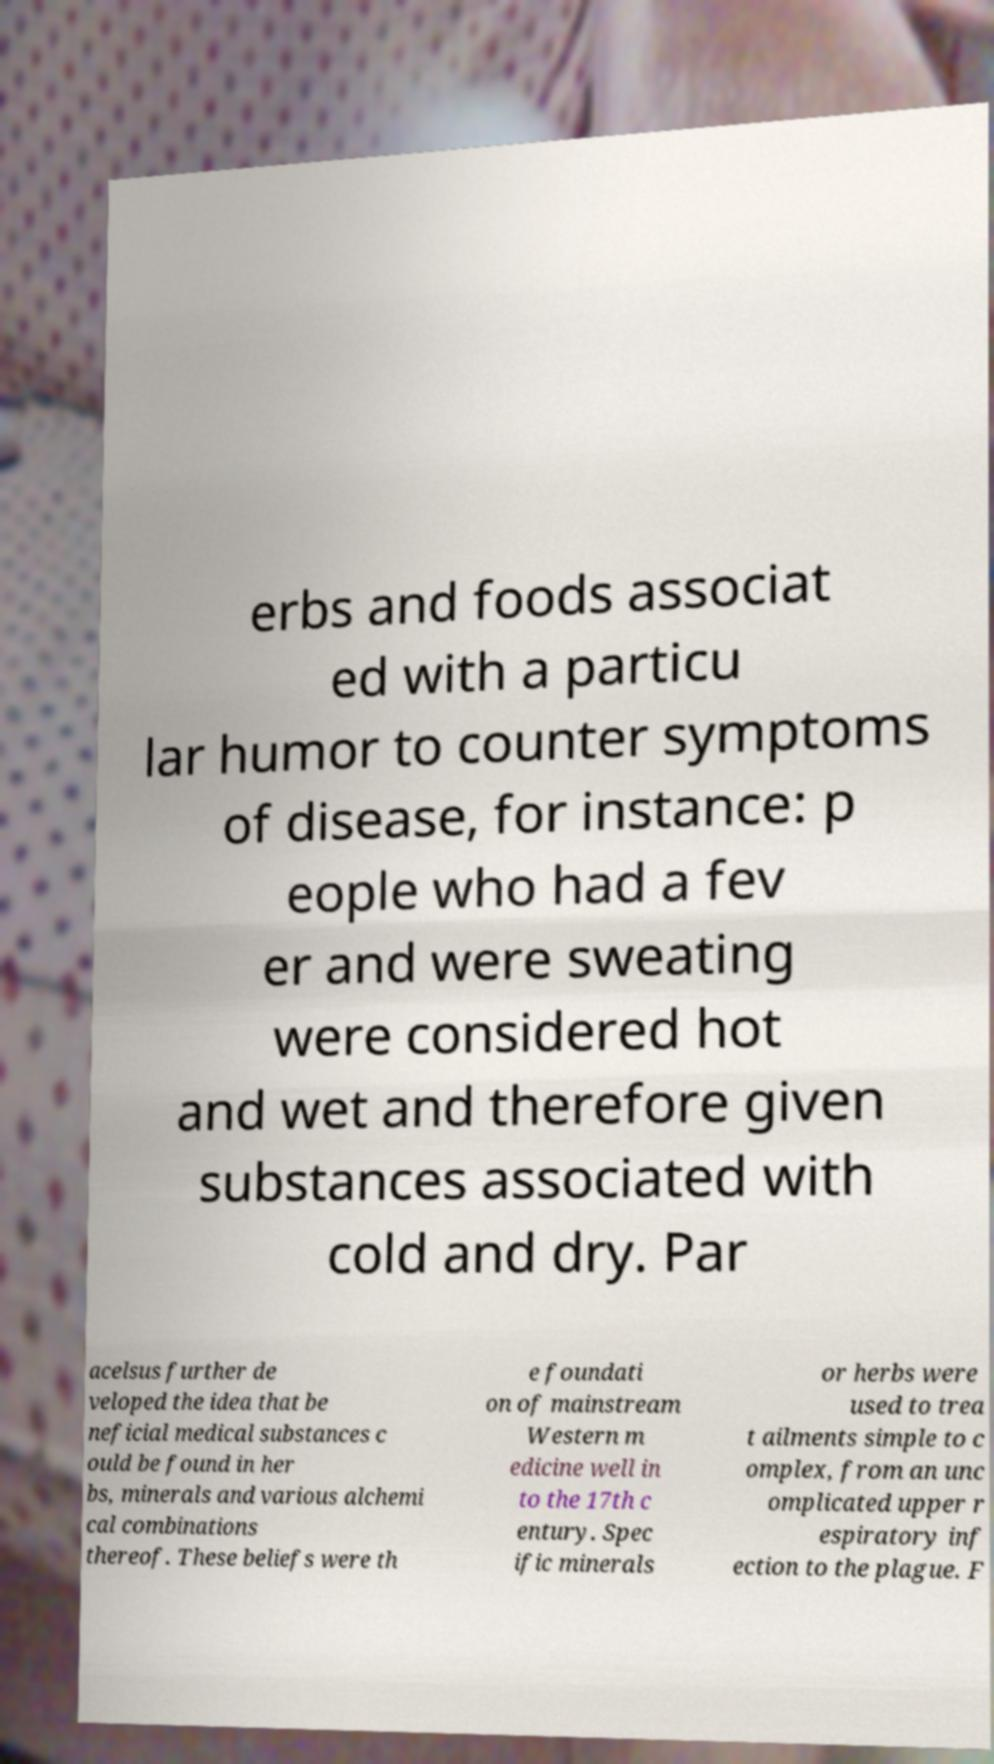For documentation purposes, I need the text within this image transcribed. Could you provide that? erbs and foods associat ed with a particu lar humor to counter symptoms of disease, for instance: p eople who had a fev er and were sweating were considered hot and wet and therefore given substances associated with cold and dry. Par acelsus further de veloped the idea that be neficial medical substances c ould be found in her bs, minerals and various alchemi cal combinations thereof. These beliefs were th e foundati on of mainstream Western m edicine well in to the 17th c entury. Spec ific minerals or herbs were used to trea t ailments simple to c omplex, from an unc omplicated upper r espiratory inf ection to the plague. F 